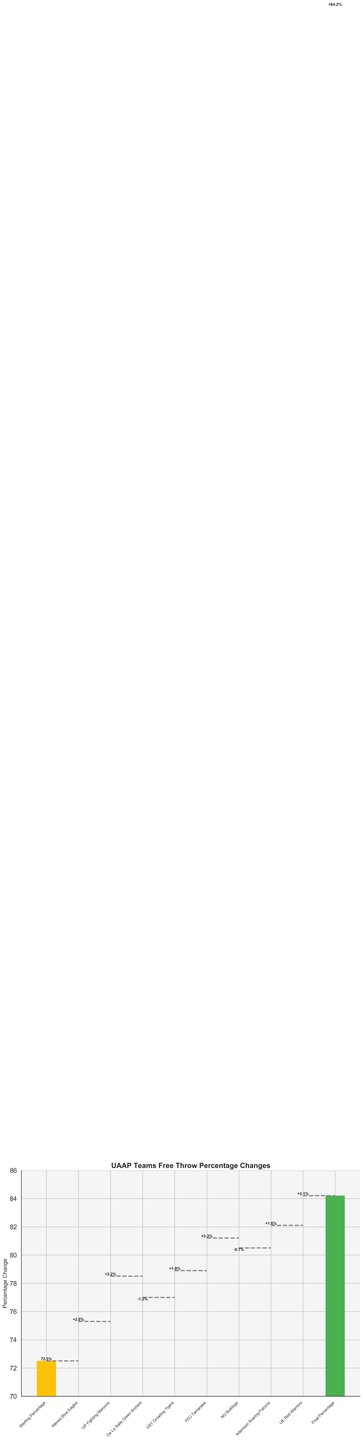What's the title of the chart? The title of the chart is located at the top and reads "UAAP Teams Free Throw Percentage Changes."
Answer: UAAP Teams Free Throw Percentage Changes What's the final free throw percentage after all the changes? The final free throw percentage is labeled as "Final Percentage" and its value is 84.2%.
Answer: 84.2% Which team had the highest positive change in free throw percentage? By scanning the chart's bars which show positive values, we see the UP Fighting Maroons had the highest positive change of +3.2%.
Answer: UP Fighting Maroons How many teams had a positive change in their free throw percentages? Count the bars with labels indicating positive changes. There are Ateneo Blue Eagles, UP Fighting Maroons, UST Growling Tigers, FEU Tamaraws, Adamson Soaring Falcons, and UE Red Warriors. This totals 6 teams.
Answer: 6 Which teams had a negative change in their free throw percentage? By identifying the bars with labels indicating a negative change, we see De La Salle Green Archers and NU Bulldogs had negative changes.
Answer: De La Salle Green Archers and NU Bulldogs What was the initial free throw percentage before any changes? The initial free throw percentage is represented by the first bar and labeled "Starting Percentage," which shows a value of 72.5%.
Answer: 72.5% What is the combined change in free throw percentage for FEU Tamaraws and UE Red Warriors? Add the changes for FEU Tamaraws (+2.3%) and UE Red Warriors (+2.1%). The combined change is 2.3 + 2.1 = 4.4%.
Answer: 4.4% Which team had the smallest change in their free throw percentage? By looking at the positive and negative changes, the NU Bulldogs had the smallest change with -0.7%.
Answer: NU Bulldogs Is the overall trend in free throw percentage changes positive or negative? Summing the positive and negative values shows more bars with positive changes, and the final percentage is significantly higher than the initial (84.2% from 72.5%). Thus, the overall trend is positive.
Answer: Positive 